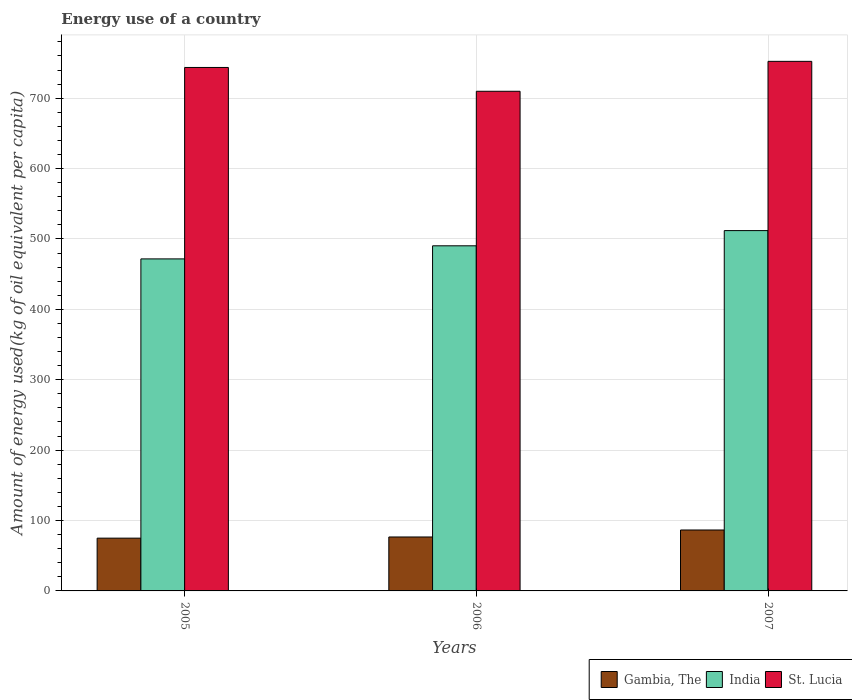How many groups of bars are there?
Your response must be concise. 3. Are the number of bars on each tick of the X-axis equal?
Give a very brief answer. Yes. How many bars are there on the 3rd tick from the right?
Your answer should be compact. 3. What is the label of the 1st group of bars from the left?
Keep it short and to the point. 2005. In how many cases, is the number of bars for a given year not equal to the number of legend labels?
Make the answer very short. 0. What is the amount of energy used in in Gambia, The in 2005?
Keep it short and to the point. 74.97. Across all years, what is the maximum amount of energy used in in St. Lucia?
Your response must be concise. 752.3. Across all years, what is the minimum amount of energy used in in St. Lucia?
Give a very brief answer. 709.79. In which year was the amount of energy used in in India maximum?
Keep it short and to the point. 2007. In which year was the amount of energy used in in St. Lucia minimum?
Your answer should be compact. 2006. What is the total amount of energy used in in India in the graph?
Ensure brevity in your answer.  1473.8. What is the difference between the amount of energy used in in St. Lucia in 2005 and that in 2006?
Give a very brief answer. 33.83. What is the difference between the amount of energy used in in St. Lucia in 2005 and the amount of energy used in in Gambia, The in 2006?
Make the answer very short. 666.99. What is the average amount of energy used in in St. Lucia per year?
Make the answer very short. 735.23. In the year 2005, what is the difference between the amount of energy used in in India and amount of energy used in in Gambia, The?
Give a very brief answer. 396.69. In how many years, is the amount of energy used in in Gambia, The greater than 460 kg?
Give a very brief answer. 0. What is the ratio of the amount of energy used in in India in 2005 to that in 2007?
Make the answer very short. 0.92. Is the difference between the amount of energy used in in India in 2006 and 2007 greater than the difference between the amount of energy used in in Gambia, The in 2006 and 2007?
Offer a very short reply. No. What is the difference between the highest and the second highest amount of energy used in in Gambia, The?
Give a very brief answer. 9.94. What is the difference between the highest and the lowest amount of energy used in in Gambia, The?
Ensure brevity in your answer.  11.59. What does the 2nd bar from the left in 2005 represents?
Provide a succinct answer. India. What does the 1st bar from the right in 2007 represents?
Give a very brief answer. St. Lucia. Is it the case that in every year, the sum of the amount of energy used in in Gambia, The and amount of energy used in in India is greater than the amount of energy used in in St. Lucia?
Offer a terse response. No. How many bars are there?
Ensure brevity in your answer.  9. What is the difference between two consecutive major ticks on the Y-axis?
Provide a short and direct response. 100. Are the values on the major ticks of Y-axis written in scientific E-notation?
Ensure brevity in your answer.  No. Does the graph contain grids?
Make the answer very short. Yes. Where does the legend appear in the graph?
Provide a succinct answer. Bottom right. How are the legend labels stacked?
Your answer should be compact. Horizontal. What is the title of the graph?
Keep it short and to the point. Energy use of a country. Does "Nepal" appear as one of the legend labels in the graph?
Provide a short and direct response. No. What is the label or title of the X-axis?
Ensure brevity in your answer.  Years. What is the label or title of the Y-axis?
Keep it short and to the point. Amount of energy used(kg of oil equivalent per capita). What is the Amount of energy used(kg of oil equivalent per capita) in Gambia, The in 2005?
Your response must be concise. 74.97. What is the Amount of energy used(kg of oil equivalent per capita) in India in 2005?
Your response must be concise. 471.66. What is the Amount of energy used(kg of oil equivalent per capita) in St. Lucia in 2005?
Your answer should be very brief. 743.62. What is the Amount of energy used(kg of oil equivalent per capita) in Gambia, The in 2006?
Your answer should be compact. 76.63. What is the Amount of energy used(kg of oil equivalent per capita) of India in 2006?
Provide a succinct answer. 490.27. What is the Amount of energy used(kg of oil equivalent per capita) of St. Lucia in 2006?
Ensure brevity in your answer.  709.79. What is the Amount of energy used(kg of oil equivalent per capita) in Gambia, The in 2007?
Your response must be concise. 86.56. What is the Amount of energy used(kg of oil equivalent per capita) of India in 2007?
Offer a very short reply. 511.87. What is the Amount of energy used(kg of oil equivalent per capita) of St. Lucia in 2007?
Offer a terse response. 752.3. Across all years, what is the maximum Amount of energy used(kg of oil equivalent per capita) of Gambia, The?
Offer a very short reply. 86.56. Across all years, what is the maximum Amount of energy used(kg of oil equivalent per capita) of India?
Offer a terse response. 511.87. Across all years, what is the maximum Amount of energy used(kg of oil equivalent per capita) in St. Lucia?
Your answer should be compact. 752.3. Across all years, what is the minimum Amount of energy used(kg of oil equivalent per capita) of Gambia, The?
Your response must be concise. 74.97. Across all years, what is the minimum Amount of energy used(kg of oil equivalent per capita) of India?
Your response must be concise. 471.66. Across all years, what is the minimum Amount of energy used(kg of oil equivalent per capita) of St. Lucia?
Provide a succinct answer. 709.79. What is the total Amount of energy used(kg of oil equivalent per capita) in Gambia, The in the graph?
Provide a succinct answer. 238.16. What is the total Amount of energy used(kg of oil equivalent per capita) in India in the graph?
Make the answer very short. 1473.8. What is the total Amount of energy used(kg of oil equivalent per capita) of St. Lucia in the graph?
Offer a very short reply. 2205.7. What is the difference between the Amount of energy used(kg of oil equivalent per capita) of Gambia, The in 2005 and that in 2006?
Ensure brevity in your answer.  -1.66. What is the difference between the Amount of energy used(kg of oil equivalent per capita) of India in 2005 and that in 2006?
Make the answer very short. -18.6. What is the difference between the Amount of energy used(kg of oil equivalent per capita) in St. Lucia in 2005 and that in 2006?
Provide a short and direct response. 33.83. What is the difference between the Amount of energy used(kg of oil equivalent per capita) of Gambia, The in 2005 and that in 2007?
Make the answer very short. -11.59. What is the difference between the Amount of energy used(kg of oil equivalent per capita) of India in 2005 and that in 2007?
Give a very brief answer. -40.2. What is the difference between the Amount of energy used(kg of oil equivalent per capita) in St. Lucia in 2005 and that in 2007?
Your answer should be compact. -8.67. What is the difference between the Amount of energy used(kg of oil equivalent per capita) in Gambia, The in 2006 and that in 2007?
Offer a terse response. -9.94. What is the difference between the Amount of energy used(kg of oil equivalent per capita) of India in 2006 and that in 2007?
Provide a succinct answer. -21.6. What is the difference between the Amount of energy used(kg of oil equivalent per capita) of St. Lucia in 2006 and that in 2007?
Your answer should be very brief. -42.51. What is the difference between the Amount of energy used(kg of oil equivalent per capita) of Gambia, The in 2005 and the Amount of energy used(kg of oil equivalent per capita) of India in 2006?
Give a very brief answer. -415.29. What is the difference between the Amount of energy used(kg of oil equivalent per capita) in Gambia, The in 2005 and the Amount of energy used(kg of oil equivalent per capita) in St. Lucia in 2006?
Provide a succinct answer. -634.81. What is the difference between the Amount of energy used(kg of oil equivalent per capita) of India in 2005 and the Amount of energy used(kg of oil equivalent per capita) of St. Lucia in 2006?
Provide a succinct answer. -238.12. What is the difference between the Amount of energy used(kg of oil equivalent per capita) of Gambia, The in 2005 and the Amount of energy used(kg of oil equivalent per capita) of India in 2007?
Give a very brief answer. -436.9. What is the difference between the Amount of energy used(kg of oil equivalent per capita) of Gambia, The in 2005 and the Amount of energy used(kg of oil equivalent per capita) of St. Lucia in 2007?
Keep it short and to the point. -677.32. What is the difference between the Amount of energy used(kg of oil equivalent per capita) in India in 2005 and the Amount of energy used(kg of oil equivalent per capita) in St. Lucia in 2007?
Keep it short and to the point. -280.63. What is the difference between the Amount of energy used(kg of oil equivalent per capita) in Gambia, The in 2006 and the Amount of energy used(kg of oil equivalent per capita) in India in 2007?
Your response must be concise. -435.24. What is the difference between the Amount of energy used(kg of oil equivalent per capita) of Gambia, The in 2006 and the Amount of energy used(kg of oil equivalent per capita) of St. Lucia in 2007?
Give a very brief answer. -675.67. What is the difference between the Amount of energy used(kg of oil equivalent per capita) in India in 2006 and the Amount of energy used(kg of oil equivalent per capita) in St. Lucia in 2007?
Offer a very short reply. -262.03. What is the average Amount of energy used(kg of oil equivalent per capita) in Gambia, The per year?
Provide a succinct answer. 79.39. What is the average Amount of energy used(kg of oil equivalent per capita) in India per year?
Keep it short and to the point. 491.27. What is the average Amount of energy used(kg of oil equivalent per capita) in St. Lucia per year?
Your answer should be compact. 735.23. In the year 2005, what is the difference between the Amount of energy used(kg of oil equivalent per capita) in Gambia, The and Amount of energy used(kg of oil equivalent per capita) in India?
Give a very brief answer. -396.69. In the year 2005, what is the difference between the Amount of energy used(kg of oil equivalent per capita) of Gambia, The and Amount of energy used(kg of oil equivalent per capita) of St. Lucia?
Give a very brief answer. -668.65. In the year 2005, what is the difference between the Amount of energy used(kg of oil equivalent per capita) in India and Amount of energy used(kg of oil equivalent per capita) in St. Lucia?
Keep it short and to the point. -271.96. In the year 2006, what is the difference between the Amount of energy used(kg of oil equivalent per capita) in Gambia, The and Amount of energy used(kg of oil equivalent per capita) in India?
Give a very brief answer. -413.64. In the year 2006, what is the difference between the Amount of energy used(kg of oil equivalent per capita) of Gambia, The and Amount of energy used(kg of oil equivalent per capita) of St. Lucia?
Give a very brief answer. -633.16. In the year 2006, what is the difference between the Amount of energy used(kg of oil equivalent per capita) of India and Amount of energy used(kg of oil equivalent per capita) of St. Lucia?
Your answer should be very brief. -219.52. In the year 2007, what is the difference between the Amount of energy used(kg of oil equivalent per capita) in Gambia, The and Amount of energy used(kg of oil equivalent per capita) in India?
Provide a succinct answer. -425.3. In the year 2007, what is the difference between the Amount of energy used(kg of oil equivalent per capita) of Gambia, The and Amount of energy used(kg of oil equivalent per capita) of St. Lucia?
Your response must be concise. -665.73. In the year 2007, what is the difference between the Amount of energy used(kg of oil equivalent per capita) of India and Amount of energy used(kg of oil equivalent per capita) of St. Lucia?
Keep it short and to the point. -240.43. What is the ratio of the Amount of energy used(kg of oil equivalent per capita) in Gambia, The in 2005 to that in 2006?
Offer a very short reply. 0.98. What is the ratio of the Amount of energy used(kg of oil equivalent per capita) of India in 2005 to that in 2006?
Ensure brevity in your answer.  0.96. What is the ratio of the Amount of energy used(kg of oil equivalent per capita) in St. Lucia in 2005 to that in 2006?
Your response must be concise. 1.05. What is the ratio of the Amount of energy used(kg of oil equivalent per capita) of Gambia, The in 2005 to that in 2007?
Your answer should be very brief. 0.87. What is the ratio of the Amount of energy used(kg of oil equivalent per capita) of India in 2005 to that in 2007?
Your response must be concise. 0.92. What is the ratio of the Amount of energy used(kg of oil equivalent per capita) of St. Lucia in 2005 to that in 2007?
Provide a succinct answer. 0.99. What is the ratio of the Amount of energy used(kg of oil equivalent per capita) of Gambia, The in 2006 to that in 2007?
Give a very brief answer. 0.89. What is the ratio of the Amount of energy used(kg of oil equivalent per capita) of India in 2006 to that in 2007?
Offer a very short reply. 0.96. What is the ratio of the Amount of energy used(kg of oil equivalent per capita) in St. Lucia in 2006 to that in 2007?
Provide a short and direct response. 0.94. What is the difference between the highest and the second highest Amount of energy used(kg of oil equivalent per capita) of Gambia, The?
Provide a short and direct response. 9.94. What is the difference between the highest and the second highest Amount of energy used(kg of oil equivalent per capita) of India?
Give a very brief answer. 21.6. What is the difference between the highest and the second highest Amount of energy used(kg of oil equivalent per capita) in St. Lucia?
Provide a short and direct response. 8.67. What is the difference between the highest and the lowest Amount of energy used(kg of oil equivalent per capita) in Gambia, The?
Your response must be concise. 11.59. What is the difference between the highest and the lowest Amount of energy used(kg of oil equivalent per capita) in India?
Ensure brevity in your answer.  40.2. What is the difference between the highest and the lowest Amount of energy used(kg of oil equivalent per capita) of St. Lucia?
Provide a short and direct response. 42.51. 